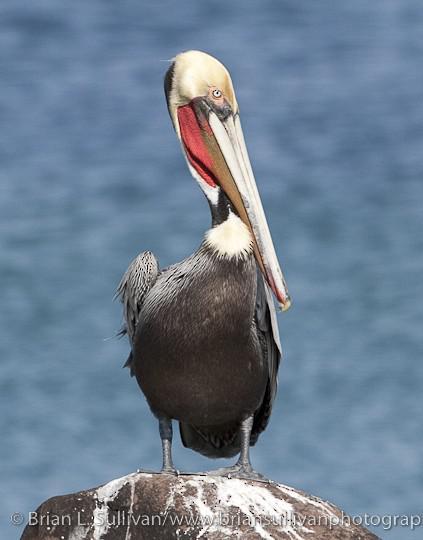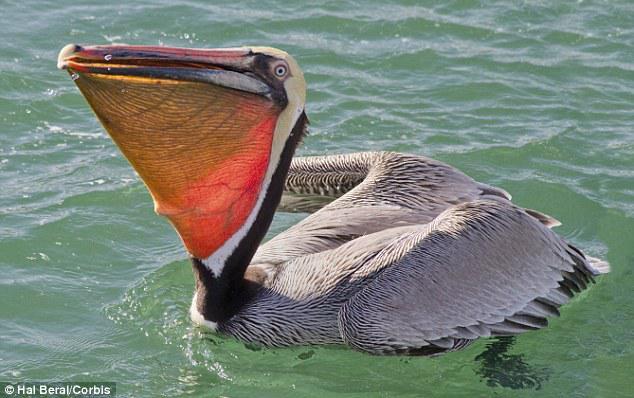The first image is the image on the left, the second image is the image on the right. For the images shown, is this caption "The left image features one pelican standing on a smooth rock, and the right image features one pelican swimming on water." true? Answer yes or no. Yes. 